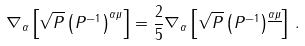<formula> <loc_0><loc_0><loc_500><loc_500>\nabla _ { \alpha } \left [ \sqrt { P } \left ( P ^ { - 1 } \right ) ^ { \alpha \mu } \right ] = \frac { 2 } { 5 } \nabla _ { \alpha } \left [ \sqrt { P } \left ( P ^ { - 1 } \right ) ^ { \underline { \alpha \mu } } \right ] \, .</formula> 